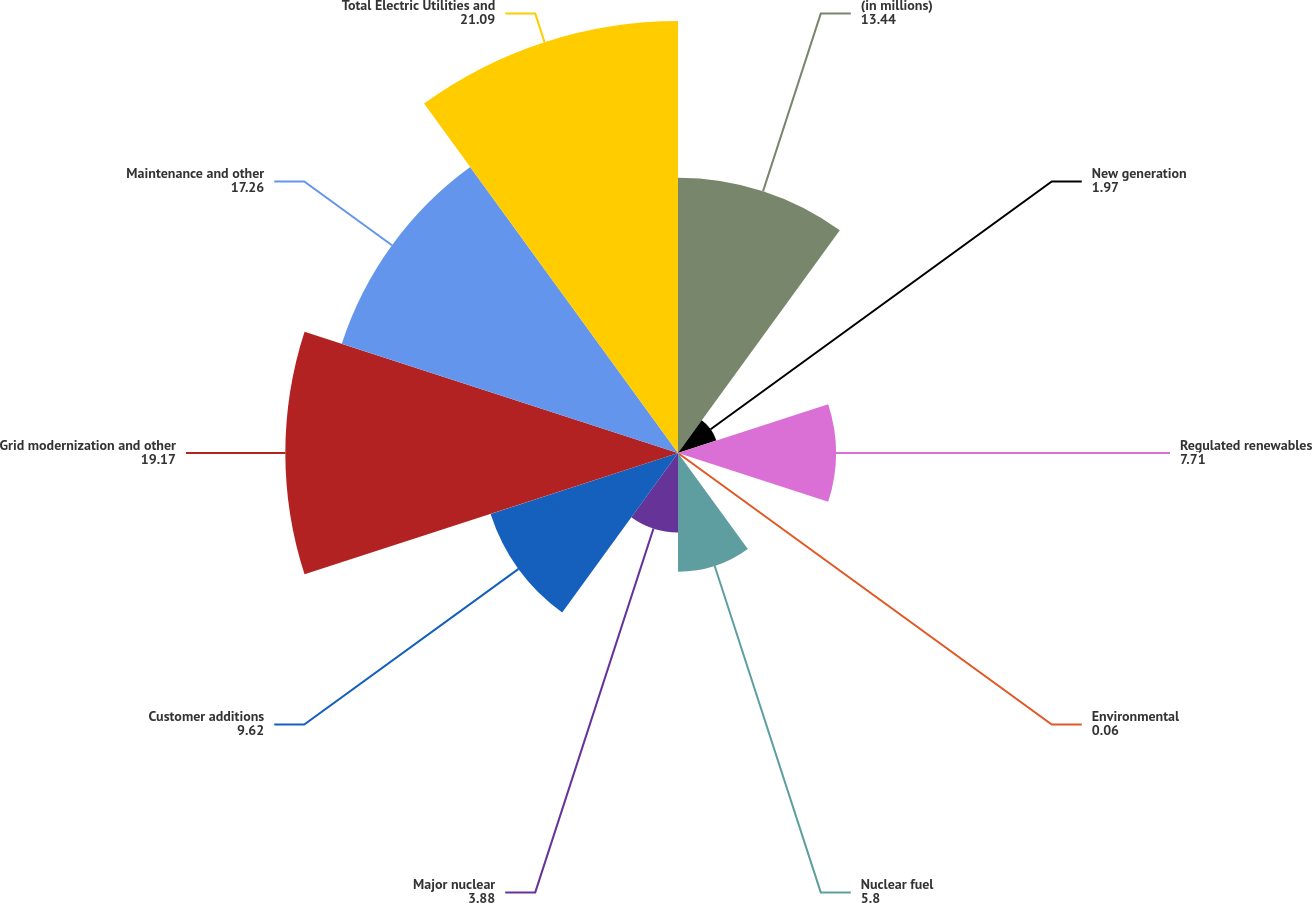Convert chart. <chart><loc_0><loc_0><loc_500><loc_500><pie_chart><fcel>(in millions)<fcel>New generation<fcel>Regulated renewables<fcel>Environmental<fcel>Nuclear fuel<fcel>Major nuclear<fcel>Customer additions<fcel>Grid modernization and other<fcel>Maintenance and other<fcel>Total Electric Utilities and<nl><fcel>13.44%<fcel>1.97%<fcel>7.71%<fcel>0.06%<fcel>5.8%<fcel>3.88%<fcel>9.62%<fcel>19.17%<fcel>17.26%<fcel>21.09%<nl></chart> 